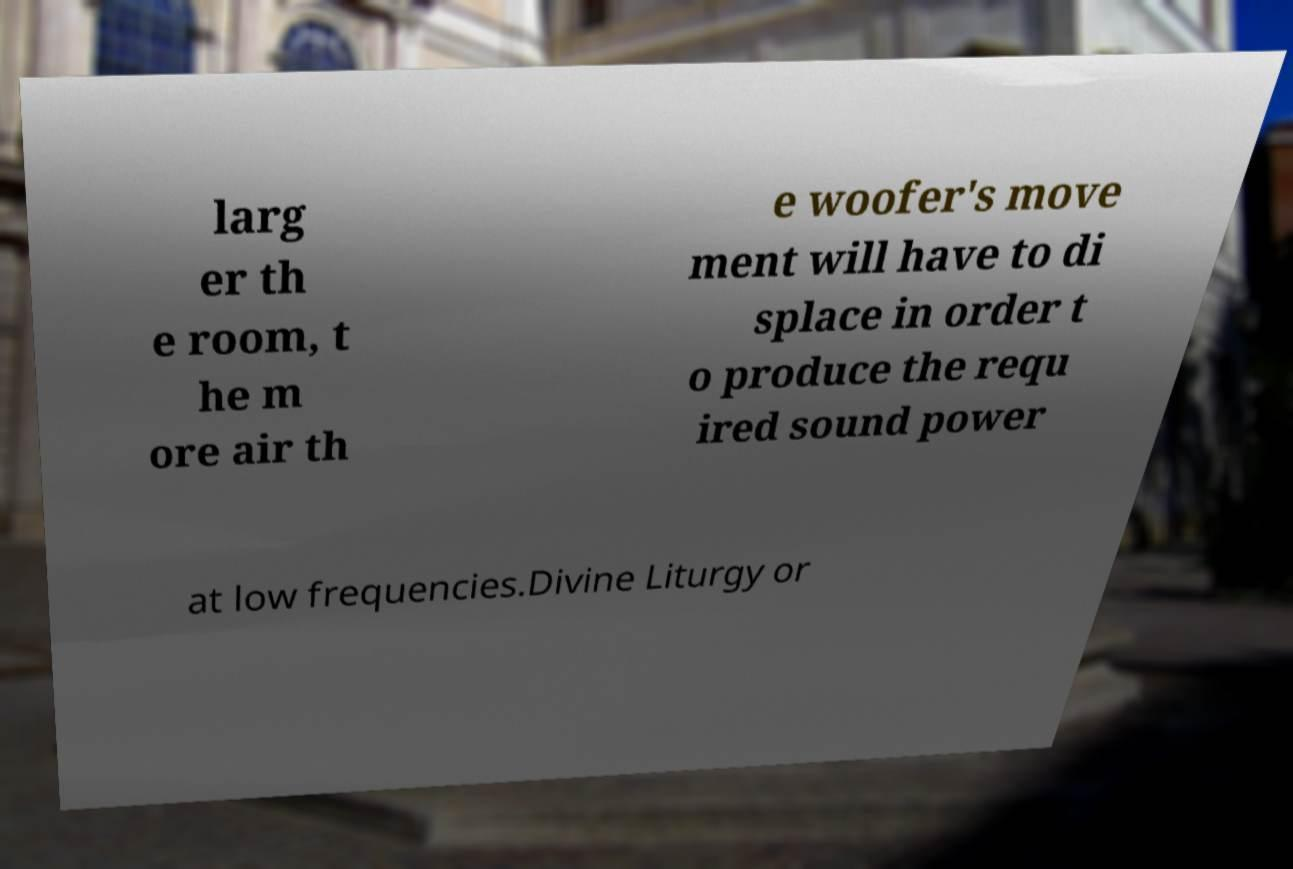Please identify and transcribe the text found in this image. larg er th e room, t he m ore air th e woofer's move ment will have to di splace in order t o produce the requ ired sound power at low frequencies.Divine Liturgy or 